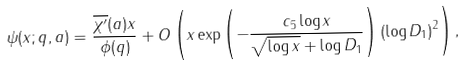<formula> <loc_0><loc_0><loc_500><loc_500>\psi ( x ; q , a ) = \frac { \overline { \chi ^ { \prime } } ( a ) x } { \phi ( q ) } + O \left ( x \exp \left ( - \frac { c _ { 5 } \log x } { \sqrt { \log x } + \log D _ { 1 } } \right ) ( \log D _ { 1 } ) ^ { 2 } \right ) ,</formula> 